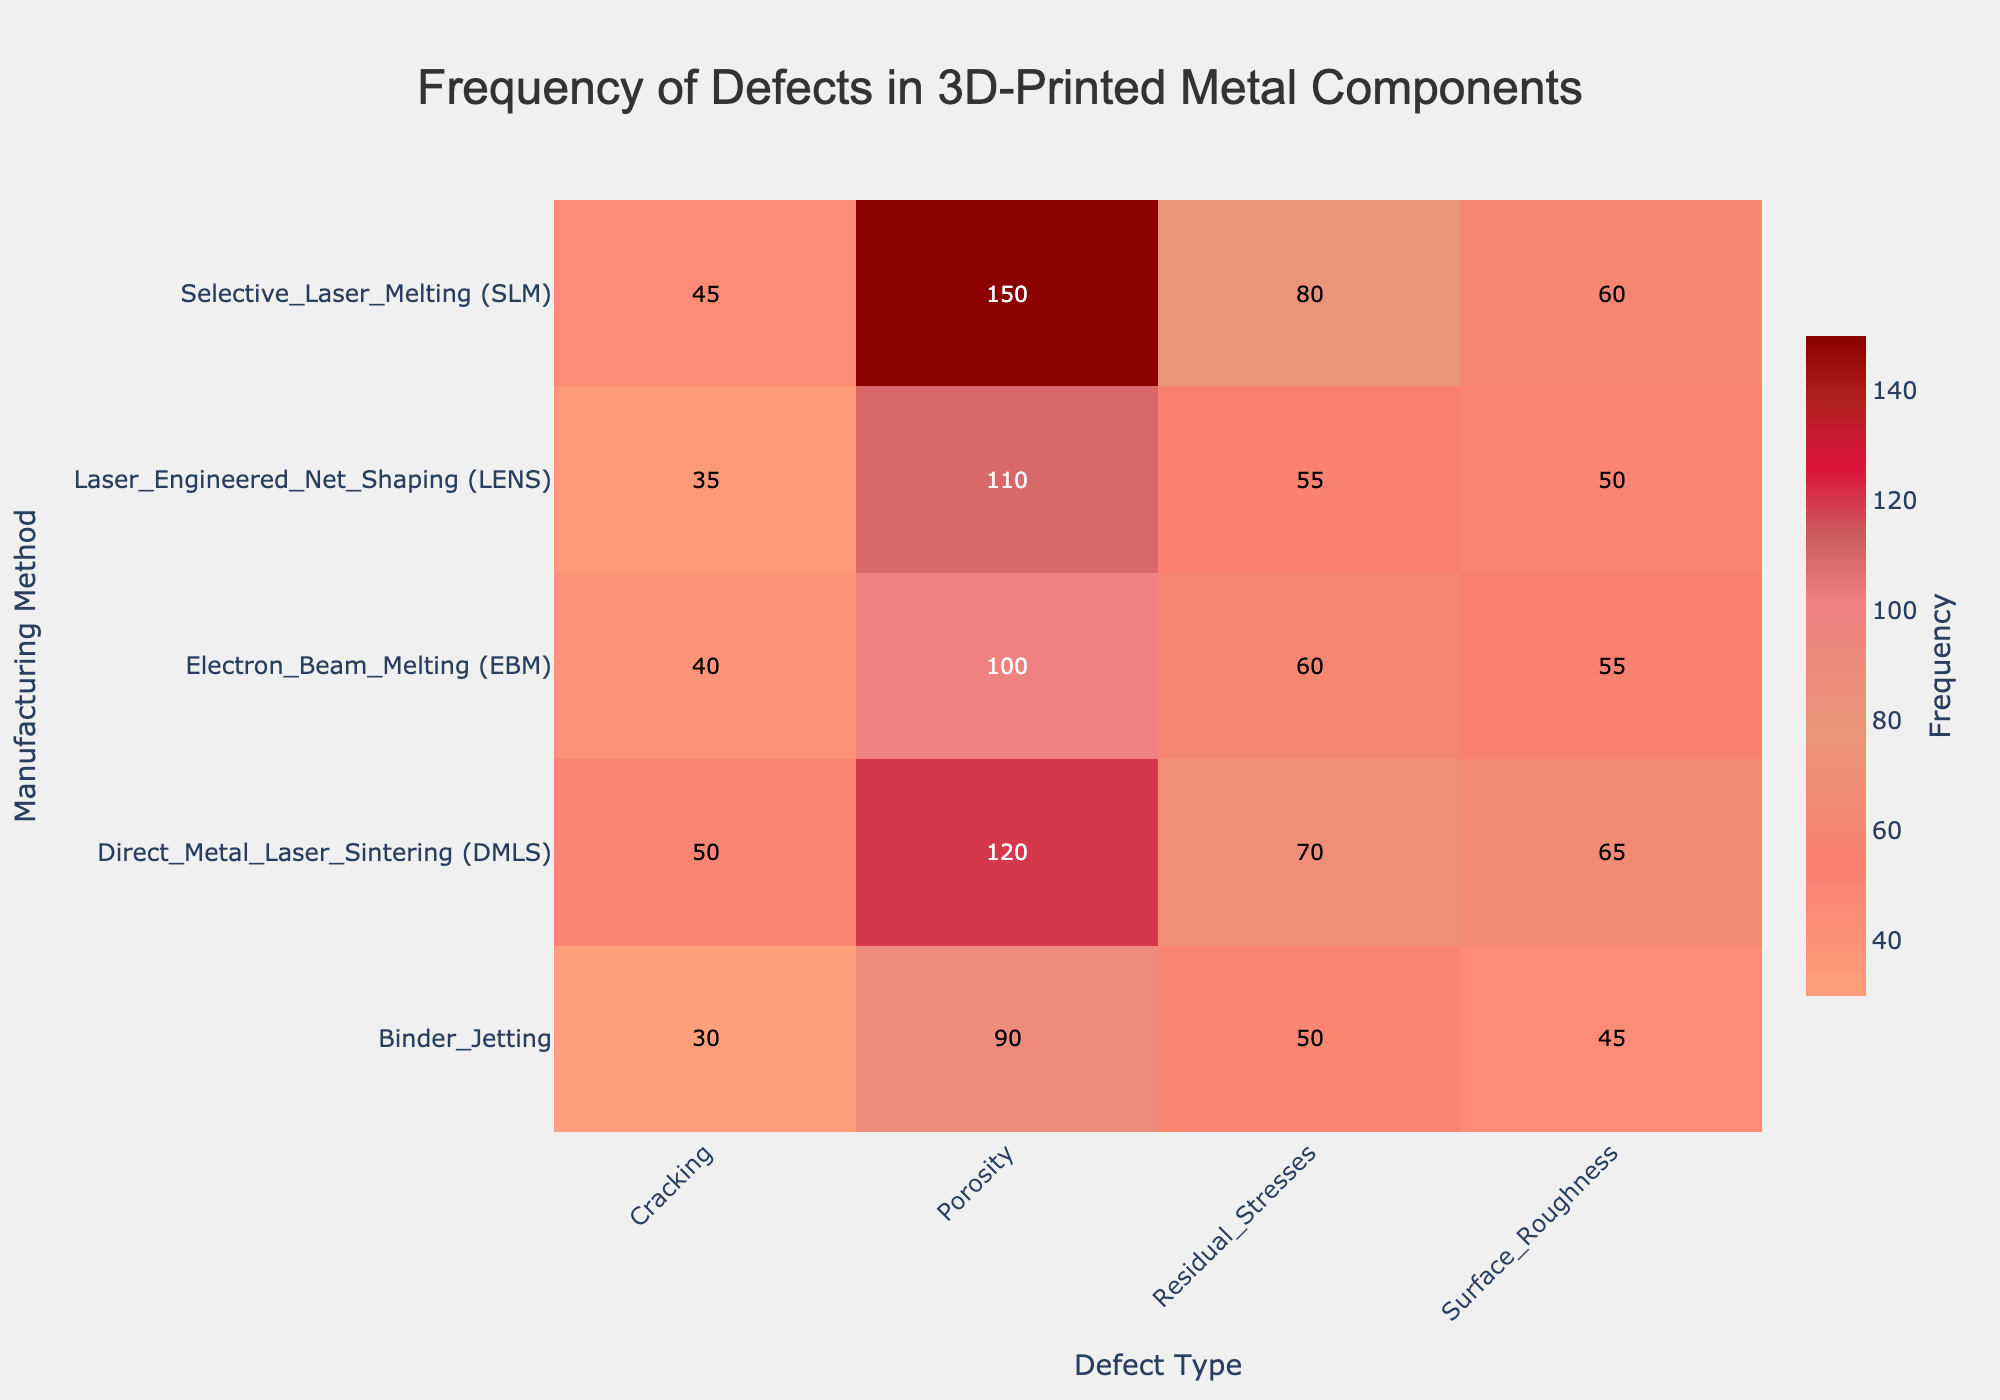Which manufacturing method has the highest frequency of porosity defects? Inspect the heatmap, locate the row corresponding to 'Porosity' defects and find the cell with the highest frequency.
Answer: Selective Laser Melting (SLM) What is the total frequency of residual stresses across all manufacturing methods? Sum the frequencies of 'Residual Stresses' defects across all manufacturing methods: 80 (SLM) + 70 (DMLS) + 60 (EBM) + 50 (Binder Jetting) + 55 (LENS) = 315.
Answer: 315 Are there more cracking defects in Direct Metal Laser Sintering (DMLS) or Electron Beam Melting (EBM)? Compare the frequencies of 'Cracking' defects for DMLS (50) and EBM (40). DMLS has a higher frequency.
Answer: Yes, DMLS Which defect type has the lowest frequency in Binder Jetting? Identify the defect type with the smallest numerical value in the 'Binder Jetting' row. 'Cracking' has the lowest frequency (30).
Answer: Cracking Which manufacturing method has the most frequent surface roughness defects? Locate the row for 'Surface Roughness' defects and find the manufacturing method with the highest frequency. DMLS has the highest frequency (65).
Answer: Direct Metal Laser Sintering (DMLS) What is the average frequency of defects in Laser Engineered Net Shaping (LENS)? Calculate the average by adding the frequencies of all defects in LENS (110 + 35 + 55 + 50) and dividing by the number of defect types (4): (110 + 35 + 55 + 50)/4 = 62.5.
Answer: 62.5 How does the frequency of porosity defects in Electron Beam Melting (EBM) compare to that in Binder Jetting? Compare the frequencies of 'Porosity' defects for EBM (100) and Binder Jetting (90). EBM has a higher frequency.
Answer: Higher in EBM What is the median frequency of defects in Selective Laser Melting (SLM)? Arrange the frequencies for SLM (150, 45, 80, 60) in ascending order: 45, 60, 80, 150. The median is the average of the two middle numbers: (60 + 80)/2 = 70.
Answer: 70 Which defect type shows the highest variation in frequency across different manufacturing methods? Assess the range of frequencies for each defect type. 'Porosity' varies from 90 to 150, 'Cracking' varies from 30 to 50, 'Residual Stresses' varies from 50 to 80, and 'Surface Roughness' varies from 45 to 65. 'Porosity' shows the highest variation (60).
Answer: Porosity 